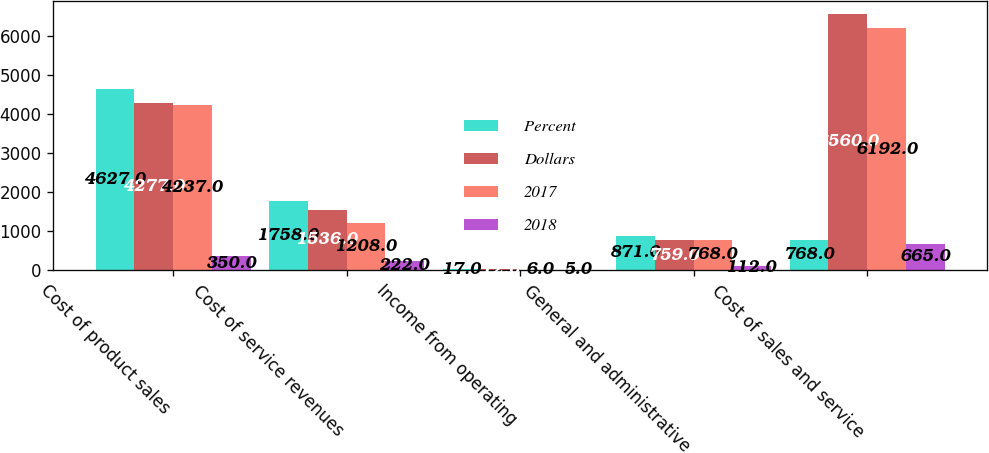<chart> <loc_0><loc_0><loc_500><loc_500><stacked_bar_chart><ecel><fcel>Cost of product sales<fcel>Cost of service revenues<fcel>Income from operating<fcel>General and administrative<fcel>Cost of sales and service<nl><fcel>Percent<fcel>4627<fcel>1758<fcel>17<fcel>871<fcel>768<nl><fcel>Dollars<fcel>4277<fcel>1536<fcel>12<fcel>759<fcel>6560<nl><fcel>2017<fcel>4237<fcel>1208<fcel>6<fcel>768<fcel>6192<nl><fcel>2018<fcel>350<fcel>222<fcel>5<fcel>112<fcel>665<nl></chart> 